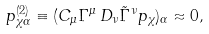<formula> <loc_0><loc_0><loc_500><loc_500>p ^ { ( 2 ) } _ { \chi \alpha } \equiv ( C _ { \mu } \Gamma ^ { \mu } \, D _ { \nu } \tilde { \Gamma } ^ { \nu } p _ { \chi } ) _ { \alpha } \approx 0 ,</formula> 